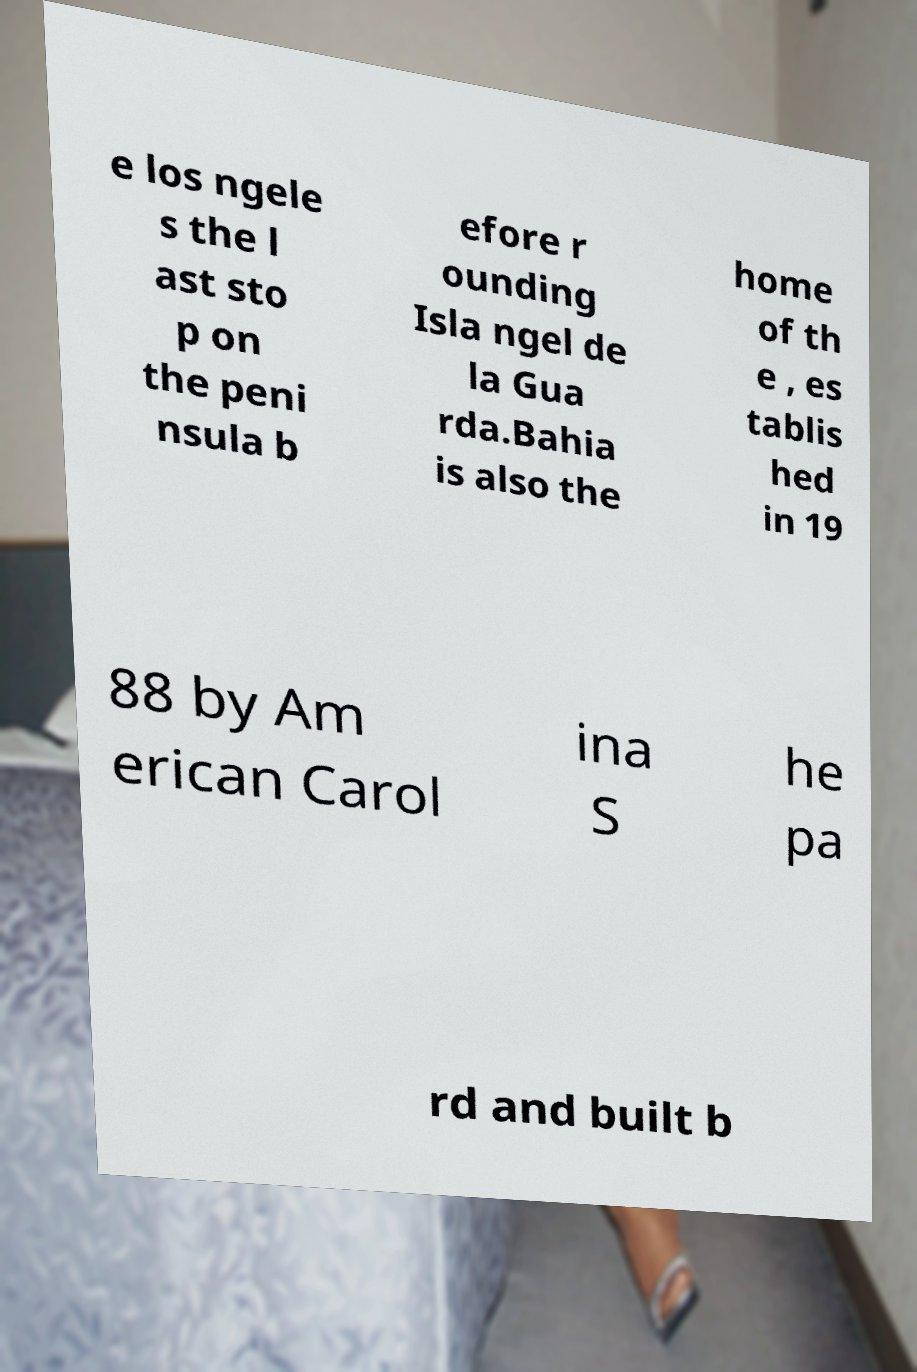Can you read and provide the text displayed in the image?This photo seems to have some interesting text. Can you extract and type it out for me? e los ngele s the l ast sto p on the peni nsula b efore r ounding Isla ngel de la Gua rda.Bahia is also the home of th e , es tablis hed in 19 88 by Am erican Carol ina S he pa rd and built b 